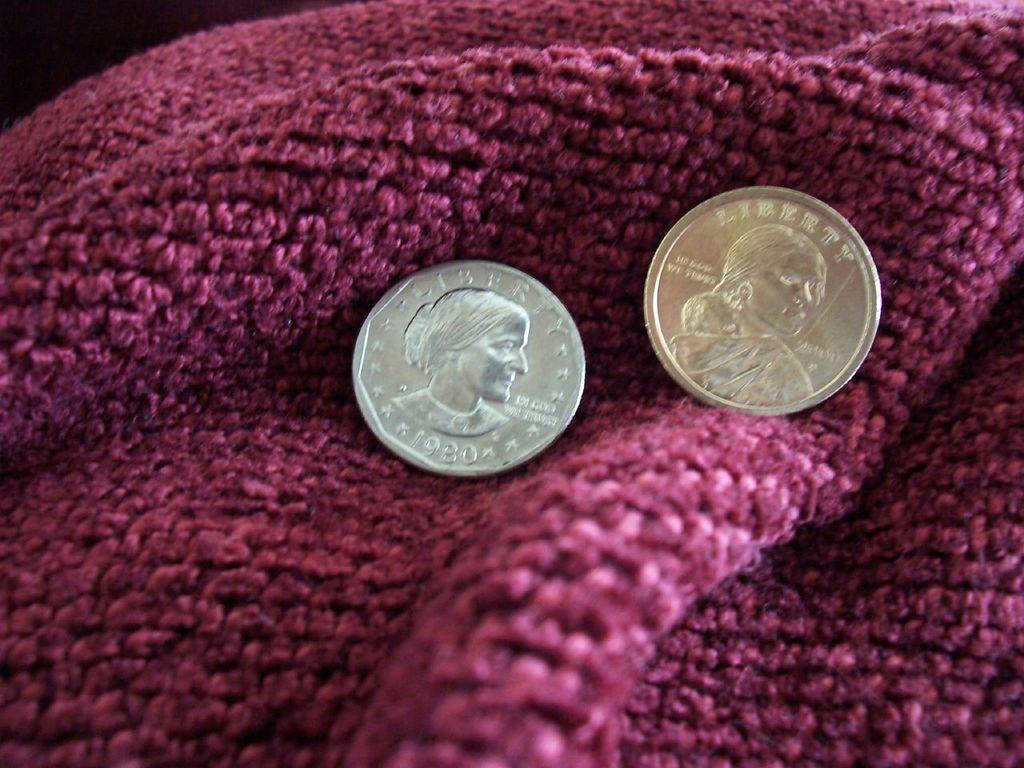<image>
Give a short and clear explanation of the subsequent image. a coin that has the word liberty on it 